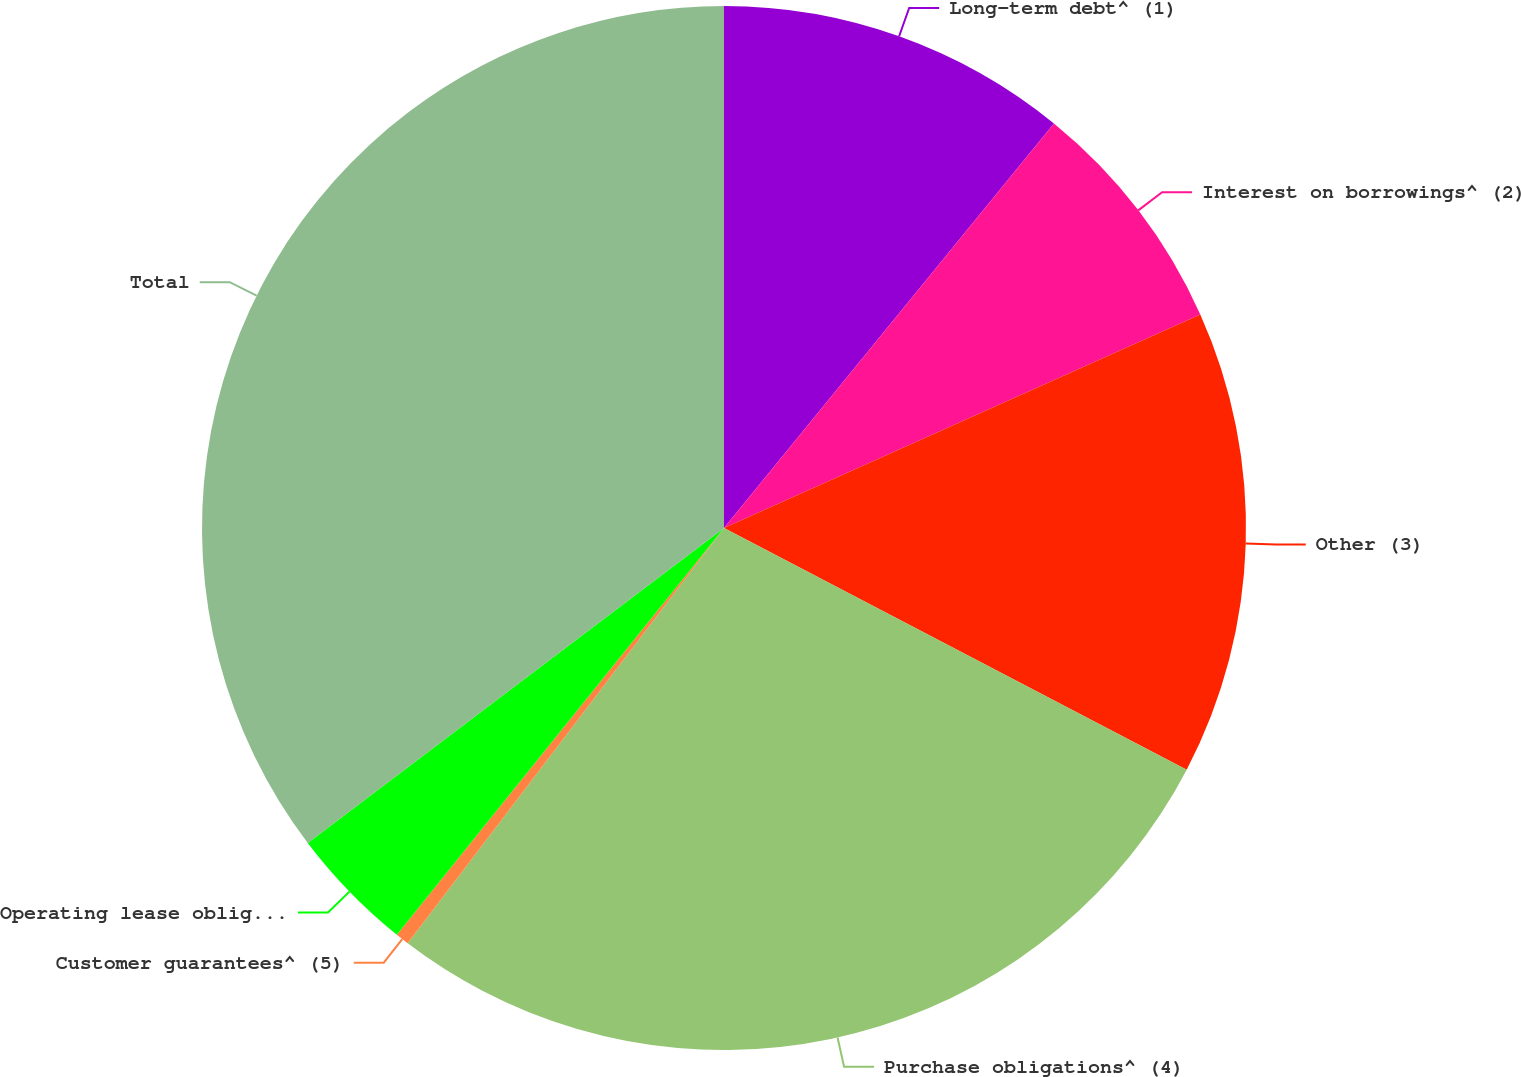Convert chart to OTSL. <chart><loc_0><loc_0><loc_500><loc_500><pie_chart><fcel>Long-term debt^ (1)<fcel>Interest on borrowings^ (2)<fcel>Other (3)<fcel>Purchase obligations^ (4)<fcel>Customer guarantees^ (5)<fcel>Operating lease obligations^<fcel>Total<nl><fcel>10.89%<fcel>7.4%<fcel>14.37%<fcel>27.7%<fcel>0.42%<fcel>3.91%<fcel>35.31%<nl></chart> 